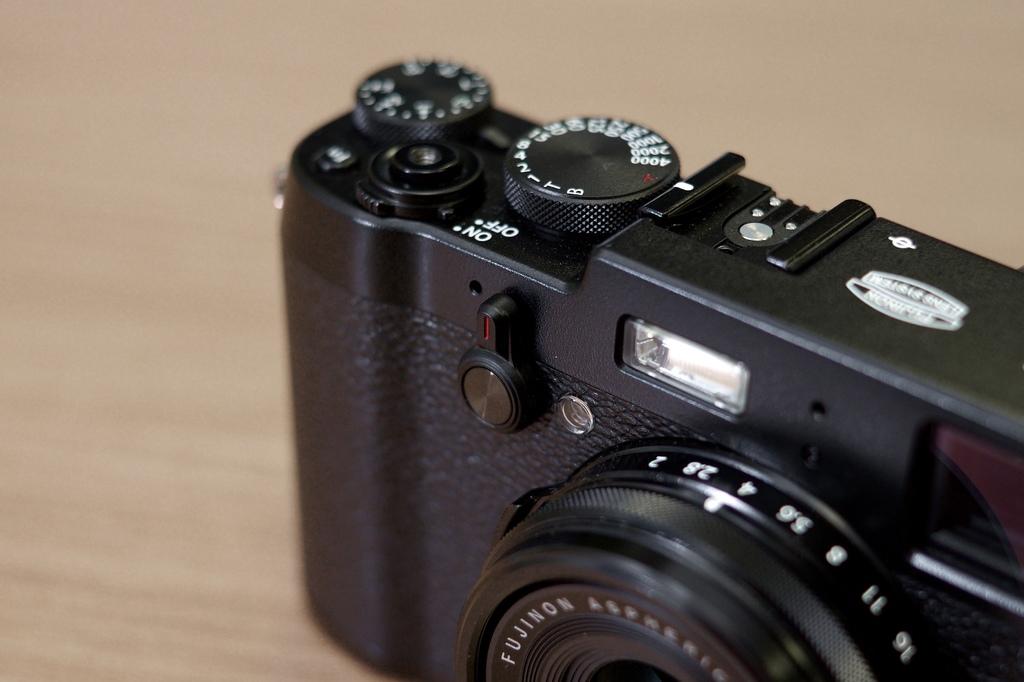What numbers are on the dial of the camera?
Make the answer very short. 1 2 4 8 15 30 60 125 250 500 1000 2000 4000. What does it say on the camera?
Your answer should be very brief. Fujinon. 